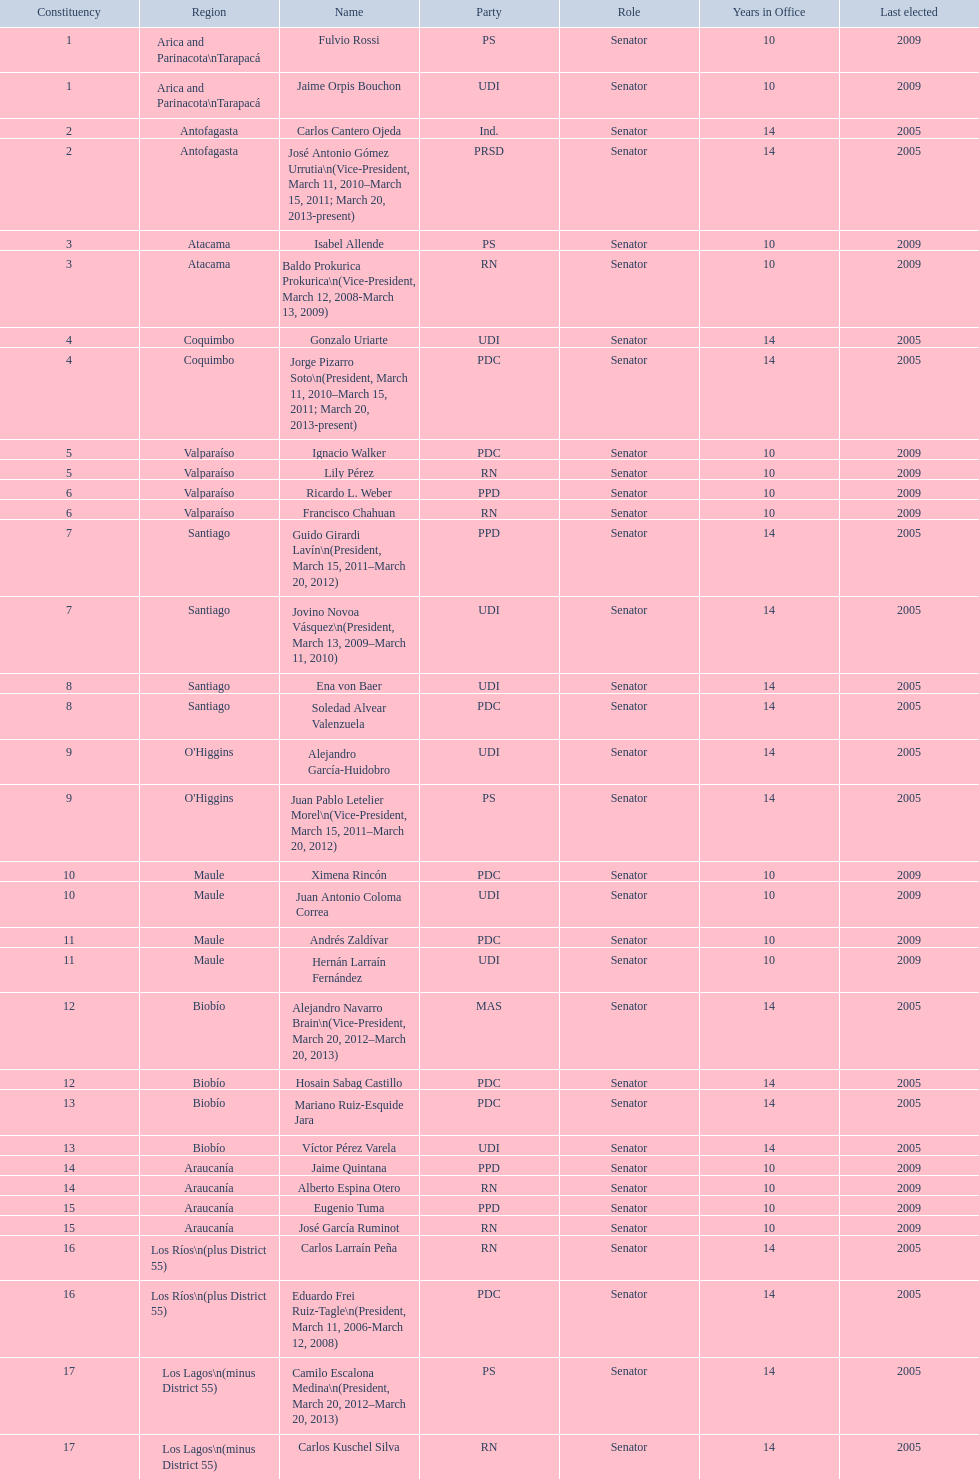Which party did jaime quintana belong to? PPD. 